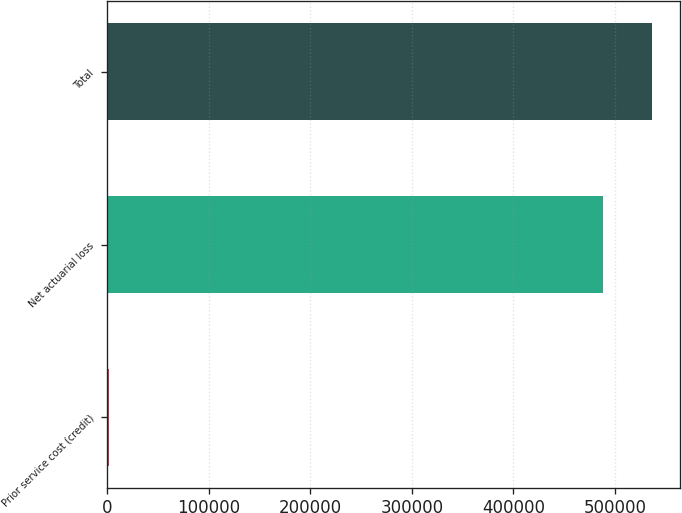Convert chart. <chart><loc_0><loc_0><loc_500><loc_500><bar_chart><fcel>Prior service cost (credit)<fcel>Net actuarial loss<fcel>Total<nl><fcel>1685<fcel>488080<fcel>536888<nl></chart> 